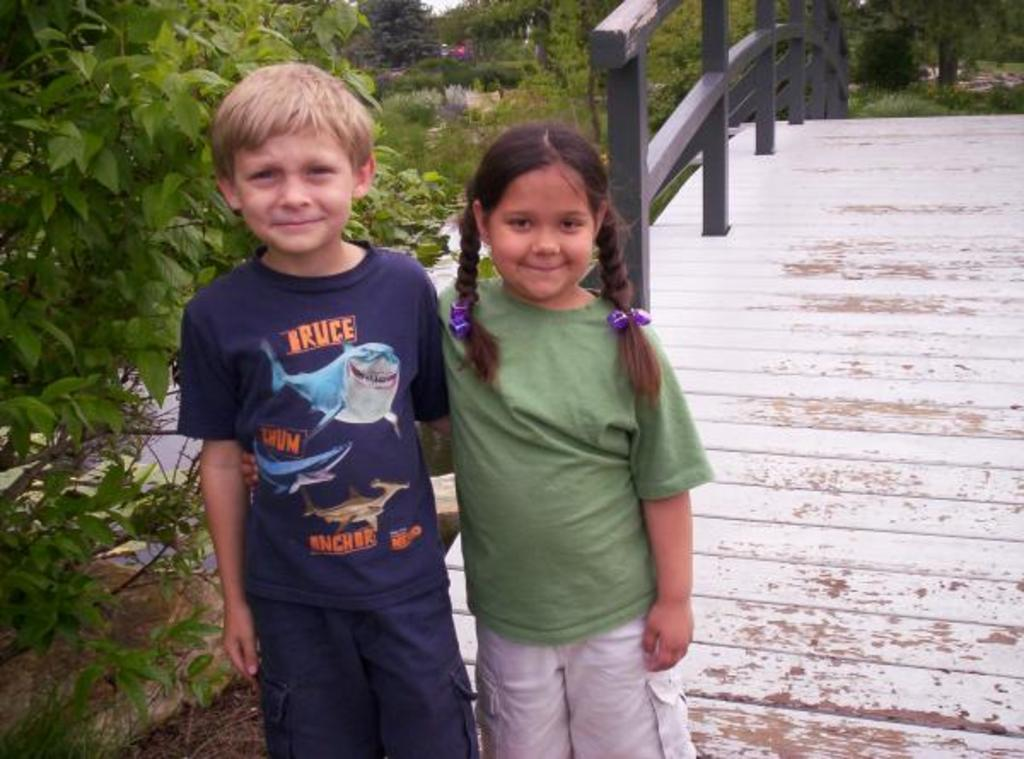How many kids are present in the image? There are two kids standing in the image. What can be seen in the background of the image? There is a wooden bridge in the image. What type of vegetation is visible in the image? There are green plants and trees in the image. What type of amusement can be seen on the wooden bridge in the image? There is no amusement present on the wooden bridge in the image; it is simply a bridge. How many hens are visible in the image? There are no hens present in the image. 